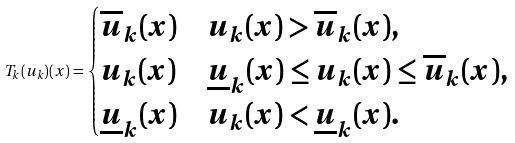Convert formula to latex. <formula><loc_0><loc_0><loc_500><loc_500>T _ { k } ( u _ { k } ) ( x ) = \begin{cases} \overline { u } _ { k } ( x ) & u _ { k } ( x ) > \overline { u } _ { k } ( x ) , \\ u _ { k } ( x ) & \underline { u } _ { k } ( x ) \leq u _ { k } ( x ) \leq \overline { u } _ { k } ( x ) , \\ \underline { u } _ { k } ( x ) & u _ { k } ( x ) < \underline { u } _ { k } ( x ) . \end{cases}</formula> 